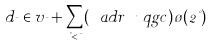<formula> <loc_0><loc_0><loc_500><loc_500>d _ { \mu } \in v _ { \mu } + \sum _ { \nu < \mu } ( \ a d r \ u q g c ) \tau ( 2 \nu )</formula> 